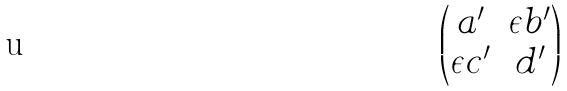Convert formula to latex. <formula><loc_0><loc_0><loc_500><loc_500>\begin{pmatrix} a ^ { \prime } & \epsilon b ^ { \prime } \\ \epsilon c ^ { \prime } & d ^ { \prime } \end{pmatrix}</formula> 